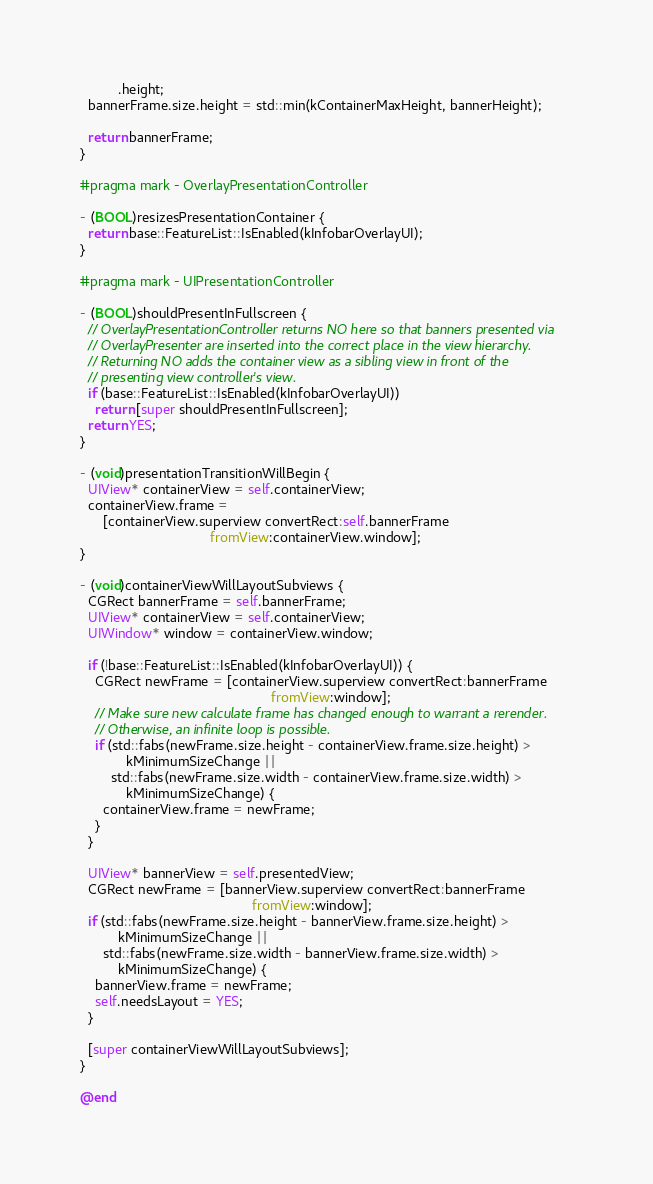<code> <loc_0><loc_0><loc_500><loc_500><_ObjectiveC_>          .height;
  bannerFrame.size.height = std::min(kContainerMaxHeight, bannerHeight);

  return bannerFrame;
}

#pragma mark - OverlayPresentationController

- (BOOL)resizesPresentationContainer {
  return base::FeatureList::IsEnabled(kInfobarOverlayUI);
}

#pragma mark - UIPresentationController

- (BOOL)shouldPresentInFullscreen {
  // OverlayPresentationController returns NO here so that banners presented via
  // OverlayPresenter are inserted into the correct place in the view hierarchy.
  // Returning NO adds the container view as a sibling view in front of the
  // presenting view controller's view.
  if (base::FeatureList::IsEnabled(kInfobarOverlayUI))
    return [super shouldPresentInFullscreen];
  return YES;
}

- (void)presentationTransitionWillBegin {
  UIView* containerView = self.containerView;
  containerView.frame =
      [containerView.superview convertRect:self.bannerFrame
                                  fromView:containerView.window];
}

- (void)containerViewWillLayoutSubviews {
  CGRect bannerFrame = self.bannerFrame;
  UIView* containerView = self.containerView;
  UIWindow* window = containerView.window;

  if (!base::FeatureList::IsEnabled(kInfobarOverlayUI)) {
    CGRect newFrame = [containerView.superview convertRect:bannerFrame
                                                  fromView:window];
    // Make sure new calculate frame has changed enough to warrant a rerender.
    // Otherwise, an infinite loop is possible.
    if (std::fabs(newFrame.size.height - containerView.frame.size.height) >
            kMinimumSizeChange ||
        std::fabs(newFrame.size.width - containerView.frame.size.width) >
            kMinimumSizeChange) {
      containerView.frame = newFrame;
    }
  }

  UIView* bannerView = self.presentedView;
  CGRect newFrame = [bannerView.superview convertRect:bannerFrame
                                             fromView:window];
  if (std::fabs(newFrame.size.height - bannerView.frame.size.height) >
          kMinimumSizeChange ||
      std::fabs(newFrame.size.width - bannerView.frame.size.width) >
          kMinimumSizeChange) {
    bannerView.frame = newFrame;
    self.needsLayout = YES;
  }

  [super containerViewWillLayoutSubviews];
}

@end
</code> 